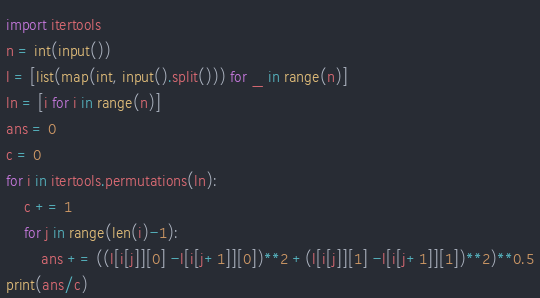<code> <loc_0><loc_0><loc_500><loc_500><_Python_>import itertools
n = int(input())
l = [list(map(int, input().split())) for _ in range(n)]
ln = [i for i in range(n)]
ans = 0
c = 0
for i in itertools.permutations(ln):
    c += 1
    for j in range(len(i)-1):
        ans += ((l[i[j]][0] -l[i[j+1]][0])**2 +(l[i[j]][1] -l[i[j+1]][1])**2)**0.5
print(ans/c)</code> 